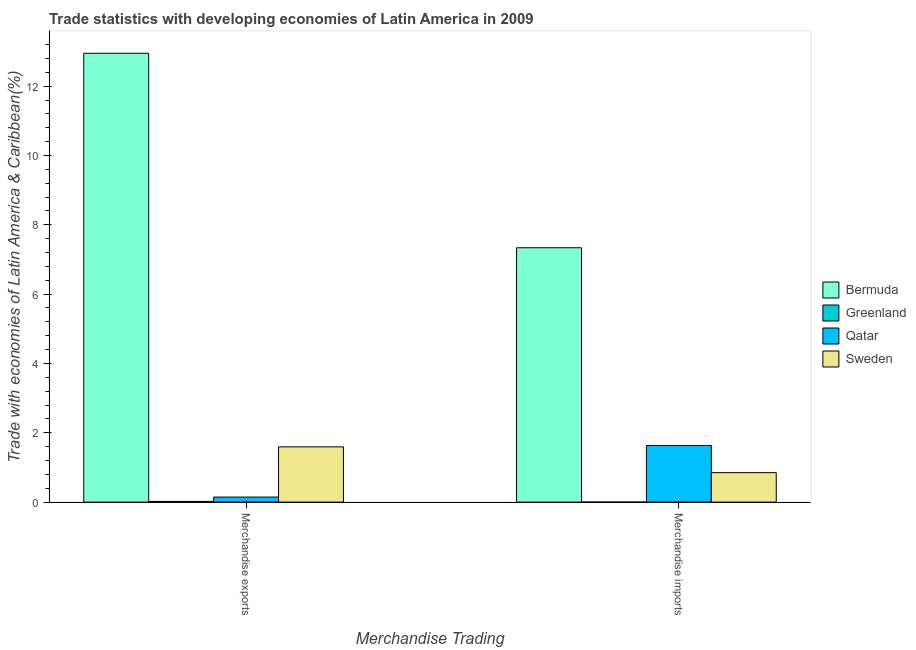How many different coloured bars are there?
Ensure brevity in your answer.  4. What is the label of the 2nd group of bars from the left?
Your response must be concise. Merchandise imports. What is the merchandise imports in Greenland?
Offer a terse response. 0. Across all countries, what is the maximum merchandise exports?
Make the answer very short. 12.95. Across all countries, what is the minimum merchandise imports?
Provide a succinct answer. 0. In which country was the merchandise exports maximum?
Give a very brief answer. Bermuda. In which country was the merchandise exports minimum?
Give a very brief answer. Greenland. What is the total merchandise exports in the graph?
Your response must be concise. 14.71. What is the difference between the merchandise imports in Bermuda and that in Sweden?
Make the answer very short. 6.49. What is the difference between the merchandise imports in Sweden and the merchandise exports in Qatar?
Your answer should be compact. 0.7. What is the average merchandise exports per country?
Give a very brief answer. 3.68. What is the difference between the merchandise exports and merchandise imports in Greenland?
Make the answer very short. 0.02. In how many countries, is the merchandise imports greater than 4.4 %?
Your answer should be very brief. 1. What is the ratio of the merchandise imports in Sweden to that in Bermuda?
Your answer should be compact. 0.12. Is the merchandise imports in Qatar less than that in Greenland?
Your response must be concise. No. What does the 4th bar from the left in Merchandise imports represents?
Your answer should be compact. Sweden. Are the values on the major ticks of Y-axis written in scientific E-notation?
Give a very brief answer. No. Where does the legend appear in the graph?
Your answer should be very brief. Center right. How many legend labels are there?
Keep it short and to the point. 4. How are the legend labels stacked?
Your answer should be very brief. Vertical. What is the title of the graph?
Keep it short and to the point. Trade statistics with developing economies of Latin America in 2009. What is the label or title of the X-axis?
Your answer should be very brief. Merchandise Trading. What is the label or title of the Y-axis?
Your answer should be very brief. Trade with economies of Latin America & Caribbean(%). What is the Trade with economies of Latin America & Caribbean(%) in Bermuda in Merchandise exports?
Make the answer very short. 12.95. What is the Trade with economies of Latin America & Caribbean(%) of Greenland in Merchandise exports?
Provide a succinct answer. 0.02. What is the Trade with economies of Latin America & Caribbean(%) of Qatar in Merchandise exports?
Provide a succinct answer. 0.15. What is the Trade with economies of Latin America & Caribbean(%) in Sweden in Merchandise exports?
Ensure brevity in your answer.  1.59. What is the Trade with economies of Latin America & Caribbean(%) in Bermuda in Merchandise imports?
Provide a short and direct response. 7.34. What is the Trade with economies of Latin America & Caribbean(%) in Greenland in Merchandise imports?
Ensure brevity in your answer.  0. What is the Trade with economies of Latin America & Caribbean(%) in Qatar in Merchandise imports?
Ensure brevity in your answer.  1.63. What is the Trade with economies of Latin America & Caribbean(%) of Sweden in Merchandise imports?
Offer a terse response. 0.85. Across all Merchandise Trading, what is the maximum Trade with economies of Latin America & Caribbean(%) in Bermuda?
Your answer should be very brief. 12.95. Across all Merchandise Trading, what is the maximum Trade with economies of Latin America & Caribbean(%) in Greenland?
Provide a short and direct response. 0.02. Across all Merchandise Trading, what is the maximum Trade with economies of Latin America & Caribbean(%) of Qatar?
Offer a terse response. 1.63. Across all Merchandise Trading, what is the maximum Trade with economies of Latin America & Caribbean(%) in Sweden?
Give a very brief answer. 1.59. Across all Merchandise Trading, what is the minimum Trade with economies of Latin America & Caribbean(%) of Bermuda?
Provide a succinct answer. 7.34. Across all Merchandise Trading, what is the minimum Trade with economies of Latin America & Caribbean(%) in Greenland?
Ensure brevity in your answer.  0. Across all Merchandise Trading, what is the minimum Trade with economies of Latin America & Caribbean(%) in Qatar?
Your answer should be very brief. 0.15. Across all Merchandise Trading, what is the minimum Trade with economies of Latin America & Caribbean(%) in Sweden?
Provide a succinct answer. 0.85. What is the total Trade with economies of Latin America & Caribbean(%) of Bermuda in the graph?
Make the answer very short. 20.29. What is the total Trade with economies of Latin America & Caribbean(%) in Greenland in the graph?
Provide a succinct answer. 0.02. What is the total Trade with economies of Latin America & Caribbean(%) of Qatar in the graph?
Your response must be concise. 1.78. What is the total Trade with economies of Latin America & Caribbean(%) of Sweden in the graph?
Give a very brief answer. 2.44. What is the difference between the Trade with economies of Latin America & Caribbean(%) in Bermuda in Merchandise exports and that in Merchandise imports?
Your answer should be very brief. 5.61. What is the difference between the Trade with economies of Latin America & Caribbean(%) in Greenland in Merchandise exports and that in Merchandise imports?
Offer a very short reply. 0.02. What is the difference between the Trade with economies of Latin America & Caribbean(%) of Qatar in Merchandise exports and that in Merchandise imports?
Provide a short and direct response. -1.49. What is the difference between the Trade with economies of Latin America & Caribbean(%) in Sweden in Merchandise exports and that in Merchandise imports?
Offer a terse response. 0.74. What is the difference between the Trade with economies of Latin America & Caribbean(%) of Bermuda in Merchandise exports and the Trade with economies of Latin America & Caribbean(%) of Greenland in Merchandise imports?
Your answer should be very brief. 12.95. What is the difference between the Trade with economies of Latin America & Caribbean(%) of Bermuda in Merchandise exports and the Trade with economies of Latin America & Caribbean(%) of Qatar in Merchandise imports?
Offer a very short reply. 11.31. What is the difference between the Trade with economies of Latin America & Caribbean(%) of Bermuda in Merchandise exports and the Trade with economies of Latin America & Caribbean(%) of Sweden in Merchandise imports?
Your answer should be very brief. 12.1. What is the difference between the Trade with economies of Latin America & Caribbean(%) of Greenland in Merchandise exports and the Trade with economies of Latin America & Caribbean(%) of Qatar in Merchandise imports?
Your response must be concise. -1.61. What is the difference between the Trade with economies of Latin America & Caribbean(%) in Greenland in Merchandise exports and the Trade with economies of Latin America & Caribbean(%) in Sweden in Merchandise imports?
Provide a succinct answer. -0.83. What is the difference between the Trade with economies of Latin America & Caribbean(%) in Qatar in Merchandise exports and the Trade with economies of Latin America & Caribbean(%) in Sweden in Merchandise imports?
Ensure brevity in your answer.  -0.7. What is the average Trade with economies of Latin America & Caribbean(%) in Bermuda per Merchandise Trading?
Offer a terse response. 10.14. What is the average Trade with economies of Latin America & Caribbean(%) of Greenland per Merchandise Trading?
Give a very brief answer. 0.01. What is the average Trade with economies of Latin America & Caribbean(%) in Qatar per Merchandise Trading?
Your response must be concise. 0.89. What is the average Trade with economies of Latin America & Caribbean(%) in Sweden per Merchandise Trading?
Your response must be concise. 1.22. What is the difference between the Trade with economies of Latin America & Caribbean(%) of Bermuda and Trade with economies of Latin America & Caribbean(%) of Greenland in Merchandise exports?
Make the answer very short. 12.93. What is the difference between the Trade with economies of Latin America & Caribbean(%) in Bermuda and Trade with economies of Latin America & Caribbean(%) in Qatar in Merchandise exports?
Provide a short and direct response. 12.8. What is the difference between the Trade with economies of Latin America & Caribbean(%) of Bermuda and Trade with economies of Latin America & Caribbean(%) of Sweden in Merchandise exports?
Make the answer very short. 11.35. What is the difference between the Trade with economies of Latin America & Caribbean(%) in Greenland and Trade with economies of Latin America & Caribbean(%) in Qatar in Merchandise exports?
Your answer should be compact. -0.12. What is the difference between the Trade with economies of Latin America & Caribbean(%) of Greenland and Trade with economies of Latin America & Caribbean(%) of Sweden in Merchandise exports?
Offer a terse response. -1.57. What is the difference between the Trade with economies of Latin America & Caribbean(%) in Qatar and Trade with economies of Latin America & Caribbean(%) in Sweden in Merchandise exports?
Offer a terse response. -1.45. What is the difference between the Trade with economies of Latin America & Caribbean(%) of Bermuda and Trade with economies of Latin America & Caribbean(%) of Greenland in Merchandise imports?
Your answer should be very brief. 7.34. What is the difference between the Trade with economies of Latin America & Caribbean(%) in Bermuda and Trade with economies of Latin America & Caribbean(%) in Qatar in Merchandise imports?
Offer a very short reply. 5.7. What is the difference between the Trade with economies of Latin America & Caribbean(%) in Bermuda and Trade with economies of Latin America & Caribbean(%) in Sweden in Merchandise imports?
Your response must be concise. 6.49. What is the difference between the Trade with economies of Latin America & Caribbean(%) in Greenland and Trade with economies of Latin America & Caribbean(%) in Qatar in Merchandise imports?
Ensure brevity in your answer.  -1.63. What is the difference between the Trade with economies of Latin America & Caribbean(%) of Greenland and Trade with economies of Latin America & Caribbean(%) of Sweden in Merchandise imports?
Offer a terse response. -0.85. What is the difference between the Trade with economies of Latin America & Caribbean(%) in Qatar and Trade with economies of Latin America & Caribbean(%) in Sweden in Merchandise imports?
Ensure brevity in your answer.  0.78. What is the ratio of the Trade with economies of Latin America & Caribbean(%) of Bermuda in Merchandise exports to that in Merchandise imports?
Make the answer very short. 1.76. What is the ratio of the Trade with economies of Latin America & Caribbean(%) in Greenland in Merchandise exports to that in Merchandise imports?
Give a very brief answer. 13.44. What is the ratio of the Trade with economies of Latin America & Caribbean(%) in Qatar in Merchandise exports to that in Merchandise imports?
Give a very brief answer. 0.09. What is the ratio of the Trade with economies of Latin America & Caribbean(%) of Sweden in Merchandise exports to that in Merchandise imports?
Give a very brief answer. 1.88. What is the difference between the highest and the second highest Trade with economies of Latin America & Caribbean(%) in Bermuda?
Your response must be concise. 5.61. What is the difference between the highest and the second highest Trade with economies of Latin America & Caribbean(%) of Greenland?
Provide a short and direct response. 0.02. What is the difference between the highest and the second highest Trade with economies of Latin America & Caribbean(%) in Qatar?
Give a very brief answer. 1.49. What is the difference between the highest and the second highest Trade with economies of Latin America & Caribbean(%) of Sweden?
Give a very brief answer. 0.74. What is the difference between the highest and the lowest Trade with economies of Latin America & Caribbean(%) of Bermuda?
Provide a succinct answer. 5.61. What is the difference between the highest and the lowest Trade with economies of Latin America & Caribbean(%) in Greenland?
Make the answer very short. 0.02. What is the difference between the highest and the lowest Trade with economies of Latin America & Caribbean(%) in Qatar?
Provide a short and direct response. 1.49. What is the difference between the highest and the lowest Trade with economies of Latin America & Caribbean(%) of Sweden?
Offer a terse response. 0.74. 